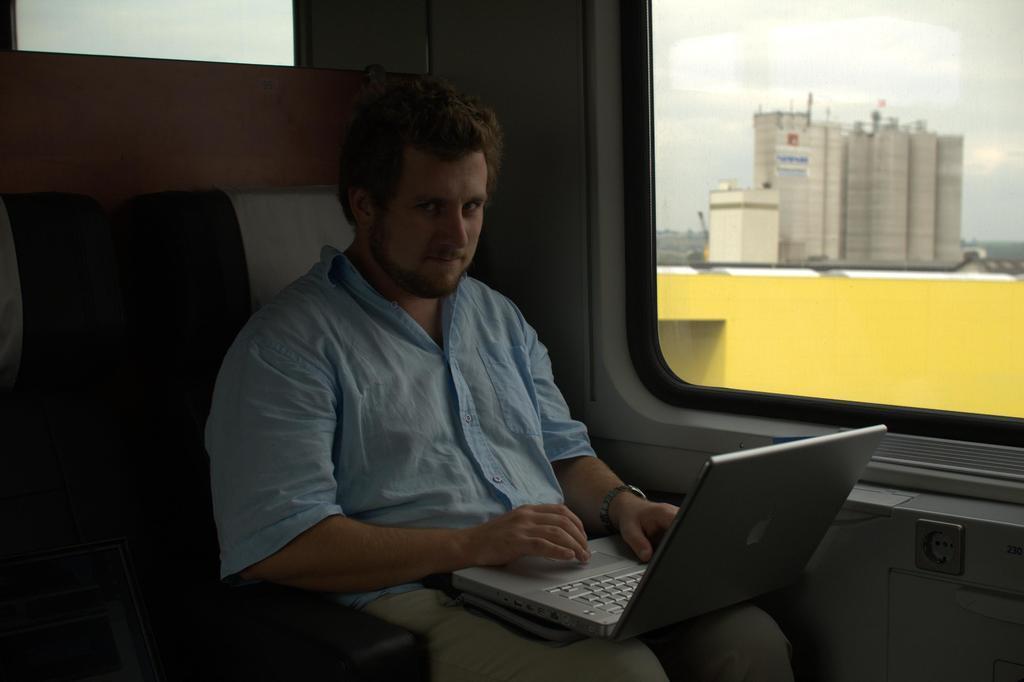Could you give a brief overview of what you see in this image? In this image there is a man sitting on chair, holding a laptop in his lap, in the background there is a glass window, through that building are visible. 